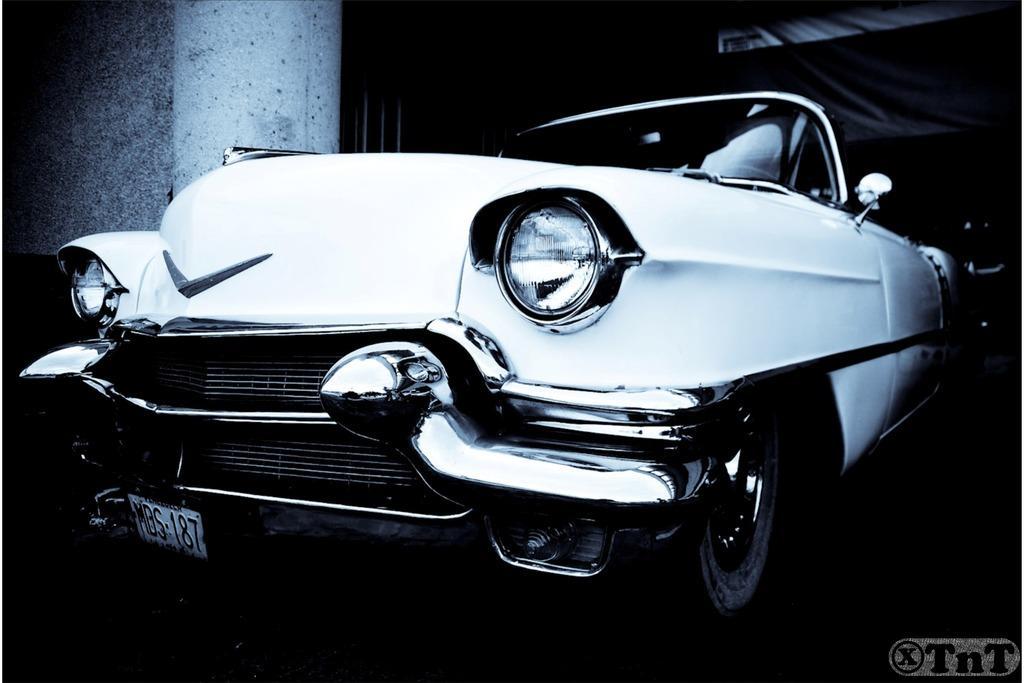Describe this image in one or two sentences. This is a black and white image and here we can see a car. In the background, there is a wall and at the bottom, there is some text. 